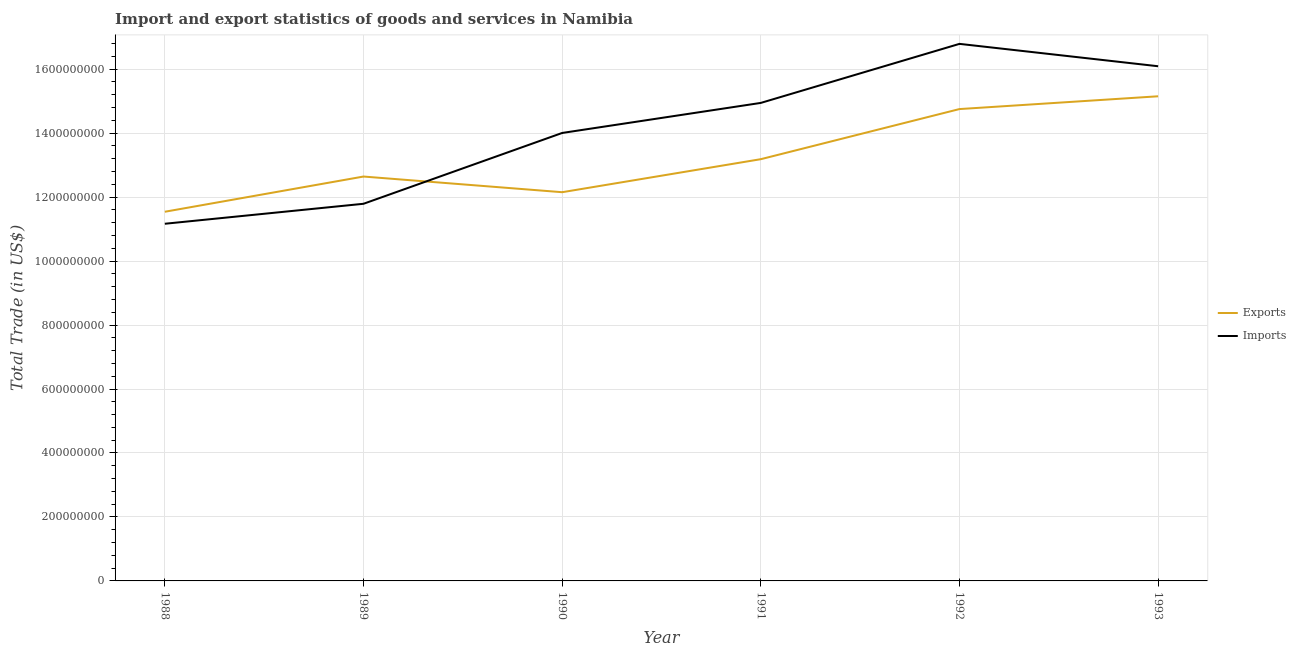How many different coloured lines are there?
Offer a very short reply. 2. Does the line corresponding to imports of goods and services intersect with the line corresponding to export of goods and services?
Make the answer very short. Yes. Is the number of lines equal to the number of legend labels?
Your answer should be very brief. Yes. What is the imports of goods and services in 1990?
Offer a terse response. 1.40e+09. Across all years, what is the maximum export of goods and services?
Offer a terse response. 1.52e+09. Across all years, what is the minimum imports of goods and services?
Offer a terse response. 1.12e+09. What is the total export of goods and services in the graph?
Make the answer very short. 7.94e+09. What is the difference between the imports of goods and services in 1989 and that in 1991?
Ensure brevity in your answer.  -3.15e+08. What is the difference between the export of goods and services in 1991 and the imports of goods and services in 1992?
Ensure brevity in your answer.  -3.61e+08. What is the average export of goods and services per year?
Provide a succinct answer. 1.32e+09. In the year 1993, what is the difference between the imports of goods and services and export of goods and services?
Keep it short and to the point. 9.39e+07. What is the ratio of the imports of goods and services in 1989 to that in 1990?
Provide a succinct answer. 0.84. Is the difference between the export of goods and services in 1990 and 1993 greater than the difference between the imports of goods and services in 1990 and 1993?
Offer a terse response. No. What is the difference between the highest and the second highest imports of goods and services?
Offer a very short reply. 7.00e+07. What is the difference between the highest and the lowest export of goods and services?
Your answer should be very brief. 3.61e+08. Is the export of goods and services strictly greater than the imports of goods and services over the years?
Give a very brief answer. No. Is the imports of goods and services strictly less than the export of goods and services over the years?
Offer a terse response. No. How many years are there in the graph?
Provide a short and direct response. 6. Are the values on the major ticks of Y-axis written in scientific E-notation?
Offer a terse response. No. Does the graph contain any zero values?
Give a very brief answer. No. Where does the legend appear in the graph?
Ensure brevity in your answer.  Center right. How many legend labels are there?
Provide a succinct answer. 2. What is the title of the graph?
Your answer should be very brief. Import and export statistics of goods and services in Namibia. What is the label or title of the Y-axis?
Offer a terse response. Total Trade (in US$). What is the Total Trade (in US$) in Exports in 1988?
Your answer should be very brief. 1.15e+09. What is the Total Trade (in US$) of Imports in 1988?
Your answer should be very brief. 1.12e+09. What is the Total Trade (in US$) of Exports in 1989?
Ensure brevity in your answer.  1.26e+09. What is the Total Trade (in US$) in Imports in 1989?
Keep it short and to the point. 1.18e+09. What is the Total Trade (in US$) of Exports in 1990?
Ensure brevity in your answer.  1.22e+09. What is the Total Trade (in US$) of Imports in 1990?
Give a very brief answer. 1.40e+09. What is the Total Trade (in US$) of Exports in 1991?
Your answer should be compact. 1.32e+09. What is the Total Trade (in US$) of Imports in 1991?
Ensure brevity in your answer.  1.49e+09. What is the Total Trade (in US$) in Exports in 1992?
Offer a very short reply. 1.48e+09. What is the Total Trade (in US$) in Imports in 1992?
Your response must be concise. 1.68e+09. What is the Total Trade (in US$) of Exports in 1993?
Your answer should be compact. 1.52e+09. What is the Total Trade (in US$) in Imports in 1993?
Provide a succinct answer. 1.61e+09. Across all years, what is the maximum Total Trade (in US$) in Exports?
Give a very brief answer. 1.52e+09. Across all years, what is the maximum Total Trade (in US$) in Imports?
Ensure brevity in your answer.  1.68e+09. Across all years, what is the minimum Total Trade (in US$) in Exports?
Make the answer very short. 1.15e+09. Across all years, what is the minimum Total Trade (in US$) of Imports?
Offer a terse response. 1.12e+09. What is the total Total Trade (in US$) of Exports in the graph?
Provide a succinct answer. 7.94e+09. What is the total Total Trade (in US$) in Imports in the graph?
Offer a very short reply. 8.48e+09. What is the difference between the Total Trade (in US$) in Exports in 1988 and that in 1989?
Offer a very short reply. -1.10e+08. What is the difference between the Total Trade (in US$) in Imports in 1988 and that in 1989?
Ensure brevity in your answer.  -6.24e+07. What is the difference between the Total Trade (in US$) of Exports in 1988 and that in 1990?
Offer a very short reply. -6.11e+07. What is the difference between the Total Trade (in US$) in Imports in 1988 and that in 1990?
Offer a very short reply. -2.84e+08. What is the difference between the Total Trade (in US$) in Exports in 1988 and that in 1991?
Your answer should be compact. -1.64e+08. What is the difference between the Total Trade (in US$) in Imports in 1988 and that in 1991?
Your response must be concise. -3.78e+08. What is the difference between the Total Trade (in US$) in Exports in 1988 and that in 1992?
Offer a terse response. -3.21e+08. What is the difference between the Total Trade (in US$) of Imports in 1988 and that in 1992?
Your response must be concise. -5.62e+08. What is the difference between the Total Trade (in US$) in Exports in 1988 and that in 1993?
Provide a succinct answer. -3.61e+08. What is the difference between the Total Trade (in US$) in Imports in 1988 and that in 1993?
Ensure brevity in your answer.  -4.92e+08. What is the difference between the Total Trade (in US$) in Exports in 1989 and that in 1990?
Your answer should be very brief. 4.90e+07. What is the difference between the Total Trade (in US$) of Imports in 1989 and that in 1990?
Your response must be concise. -2.21e+08. What is the difference between the Total Trade (in US$) of Exports in 1989 and that in 1991?
Give a very brief answer. -5.43e+07. What is the difference between the Total Trade (in US$) of Imports in 1989 and that in 1991?
Provide a succinct answer. -3.15e+08. What is the difference between the Total Trade (in US$) of Exports in 1989 and that in 1992?
Ensure brevity in your answer.  -2.11e+08. What is the difference between the Total Trade (in US$) in Imports in 1989 and that in 1992?
Your answer should be very brief. -5.00e+08. What is the difference between the Total Trade (in US$) in Exports in 1989 and that in 1993?
Offer a very short reply. -2.51e+08. What is the difference between the Total Trade (in US$) of Imports in 1989 and that in 1993?
Keep it short and to the point. -4.30e+08. What is the difference between the Total Trade (in US$) of Exports in 1990 and that in 1991?
Provide a succinct answer. -1.03e+08. What is the difference between the Total Trade (in US$) of Imports in 1990 and that in 1991?
Ensure brevity in your answer.  -9.40e+07. What is the difference between the Total Trade (in US$) in Exports in 1990 and that in 1992?
Your answer should be compact. -2.60e+08. What is the difference between the Total Trade (in US$) in Imports in 1990 and that in 1992?
Make the answer very short. -2.79e+08. What is the difference between the Total Trade (in US$) in Exports in 1990 and that in 1993?
Your answer should be compact. -3.00e+08. What is the difference between the Total Trade (in US$) in Imports in 1990 and that in 1993?
Offer a very short reply. -2.09e+08. What is the difference between the Total Trade (in US$) of Exports in 1991 and that in 1992?
Give a very brief answer. -1.57e+08. What is the difference between the Total Trade (in US$) of Imports in 1991 and that in 1992?
Make the answer very short. -1.85e+08. What is the difference between the Total Trade (in US$) of Exports in 1991 and that in 1993?
Offer a very short reply. -1.97e+08. What is the difference between the Total Trade (in US$) of Imports in 1991 and that in 1993?
Give a very brief answer. -1.15e+08. What is the difference between the Total Trade (in US$) of Exports in 1992 and that in 1993?
Ensure brevity in your answer.  -4.00e+07. What is the difference between the Total Trade (in US$) in Imports in 1992 and that in 1993?
Provide a short and direct response. 7.00e+07. What is the difference between the Total Trade (in US$) in Exports in 1988 and the Total Trade (in US$) in Imports in 1989?
Give a very brief answer. -2.49e+07. What is the difference between the Total Trade (in US$) in Exports in 1988 and the Total Trade (in US$) in Imports in 1990?
Provide a succinct answer. -2.46e+08. What is the difference between the Total Trade (in US$) in Exports in 1988 and the Total Trade (in US$) in Imports in 1991?
Your response must be concise. -3.40e+08. What is the difference between the Total Trade (in US$) of Exports in 1988 and the Total Trade (in US$) of Imports in 1992?
Provide a short and direct response. -5.25e+08. What is the difference between the Total Trade (in US$) of Exports in 1988 and the Total Trade (in US$) of Imports in 1993?
Provide a short and direct response. -4.55e+08. What is the difference between the Total Trade (in US$) in Exports in 1989 and the Total Trade (in US$) in Imports in 1990?
Ensure brevity in your answer.  -1.36e+08. What is the difference between the Total Trade (in US$) in Exports in 1989 and the Total Trade (in US$) in Imports in 1991?
Provide a succinct answer. -2.30e+08. What is the difference between the Total Trade (in US$) of Exports in 1989 and the Total Trade (in US$) of Imports in 1992?
Offer a terse response. -4.15e+08. What is the difference between the Total Trade (in US$) in Exports in 1989 and the Total Trade (in US$) in Imports in 1993?
Your response must be concise. -3.45e+08. What is the difference between the Total Trade (in US$) of Exports in 1990 and the Total Trade (in US$) of Imports in 1991?
Keep it short and to the point. -2.79e+08. What is the difference between the Total Trade (in US$) in Exports in 1990 and the Total Trade (in US$) in Imports in 1992?
Give a very brief answer. -4.64e+08. What is the difference between the Total Trade (in US$) in Exports in 1990 and the Total Trade (in US$) in Imports in 1993?
Provide a short and direct response. -3.94e+08. What is the difference between the Total Trade (in US$) in Exports in 1991 and the Total Trade (in US$) in Imports in 1992?
Ensure brevity in your answer.  -3.61e+08. What is the difference between the Total Trade (in US$) of Exports in 1991 and the Total Trade (in US$) of Imports in 1993?
Offer a very short reply. -2.91e+08. What is the difference between the Total Trade (in US$) in Exports in 1992 and the Total Trade (in US$) in Imports in 1993?
Ensure brevity in your answer.  -1.34e+08. What is the average Total Trade (in US$) in Exports per year?
Ensure brevity in your answer.  1.32e+09. What is the average Total Trade (in US$) in Imports per year?
Make the answer very short. 1.41e+09. In the year 1988, what is the difference between the Total Trade (in US$) in Exports and Total Trade (in US$) in Imports?
Give a very brief answer. 3.75e+07. In the year 1989, what is the difference between the Total Trade (in US$) of Exports and Total Trade (in US$) of Imports?
Provide a succinct answer. 8.52e+07. In the year 1990, what is the difference between the Total Trade (in US$) in Exports and Total Trade (in US$) in Imports?
Give a very brief answer. -1.85e+08. In the year 1991, what is the difference between the Total Trade (in US$) in Exports and Total Trade (in US$) in Imports?
Ensure brevity in your answer.  -1.76e+08. In the year 1992, what is the difference between the Total Trade (in US$) of Exports and Total Trade (in US$) of Imports?
Provide a short and direct response. -2.04e+08. In the year 1993, what is the difference between the Total Trade (in US$) of Exports and Total Trade (in US$) of Imports?
Make the answer very short. -9.39e+07. What is the ratio of the Total Trade (in US$) of Exports in 1988 to that in 1989?
Ensure brevity in your answer.  0.91. What is the ratio of the Total Trade (in US$) of Imports in 1988 to that in 1989?
Your answer should be compact. 0.95. What is the ratio of the Total Trade (in US$) in Exports in 1988 to that in 1990?
Make the answer very short. 0.95. What is the ratio of the Total Trade (in US$) of Imports in 1988 to that in 1990?
Give a very brief answer. 0.8. What is the ratio of the Total Trade (in US$) of Exports in 1988 to that in 1991?
Offer a terse response. 0.88. What is the ratio of the Total Trade (in US$) of Imports in 1988 to that in 1991?
Provide a succinct answer. 0.75. What is the ratio of the Total Trade (in US$) of Exports in 1988 to that in 1992?
Provide a short and direct response. 0.78. What is the ratio of the Total Trade (in US$) in Imports in 1988 to that in 1992?
Provide a short and direct response. 0.67. What is the ratio of the Total Trade (in US$) of Exports in 1988 to that in 1993?
Make the answer very short. 0.76. What is the ratio of the Total Trade (in US$) of Imports in 1988 to that in 1993?
Give a very brief answer. 0.69. What is the ratio of the Total Trade (in US$) of Exports in 1989 to that in 1990?
Offer a terse response. 1.04. What is the ratio of the Total Trade (in US$) in Imports in 1989 to that in 1990?
Ensure brevity in your answer.  0.84. What is the ratio of the Total Trade (in US$) of Exports in 1989 to that in 1991?
Provide a short and direct response. 0.96. What is the ratio of the Total Trade (in US$) in Imports in 1989 to that in 1991?
Ensure brevity in your answer.  0.79. What is the ratio of the Total Trade (in US$) in Exports in 1989 to that in 1992?
Give a very brief answer. 0.86. What is the ratio of the Total Trade (in US$) in Imports in 1989 to that in 1992?
Provide a short and direct response. 0.7. What is the ratio of the Total Trade (in US$) of Exports in 1989 to that in 1993?
Provide a succinct answer. 0.83. What is the ratio of the Total Trade (in US$) of Imports in 1989 to that in 1993?
Give a very brief answer. 0.73. What is the ratio of the Total Trade (in US$) in Exports in 1990 to that in 1991?
Keep it short and to the point. 0.92. What is the ratio of the Total Trade (in US$) of Imports in 1990 to that in 1991?
Provide a succinct answer. 0.94. What is the ratio of the Total Trade (in US$) in Exports in 1990 to that in 1992?
Provide a short and direct response. 0.82. What is the ratio of the Total Trade (in US$) of Imports in 1990 to that in 1992?
Your answer should be compact. 0.83. What is the ratio of the Total Trade (in US$) in Exports in 1990 to that in 1993?
Your response must be concise. 0.8. What is the ratio of the Total Trade (in US$) of Imports in 1990 to that in 1993?
Provide a short and direct response. 0.87. What is the ratio of the Total Trade (in US$) in Exports in 1991 to that in 1992?
Provide a short and direct response. 0.89. What is the ratio of the Total Trade (in US$) of Imports in 1991 to that in 1992?
Offer a terse response. 0.89. What is the ratio of the Total Trade (in US$) of Exports in 1991 to that in 1993?
Offer a terse response. 0.87. What is the ratio of the Total Trade (in US$) in Imports in 1991 to that in 1993?
Keep it short and to the point. 0.93. What is the ratio of the Total Trade (in US$) of Exports in 1992 to that in 1993?
Make the answer very short. 0.97. What is the ratio of the Total Trade (in US$) of Imports in 1992 to that in 1993?
Your response must be concise. 1.04. What is the difference between the highest and the second highest Total Trade (in US$) in Exports?
Make the answer very short. 4.00e+07. What is the difference between the highest and the second highest Total Trade (in US$) of Imports?
Your response must be concise. 7.00e+07. What is the difference between the highest and the lowest Total Trade (in US$) in Exports?
Your answer should be very brief. 3.61e+08. What is the difference between the highest and the lowest Total Trade (in US$) in Imports?
Make the answer very short. 5.62e+08. 